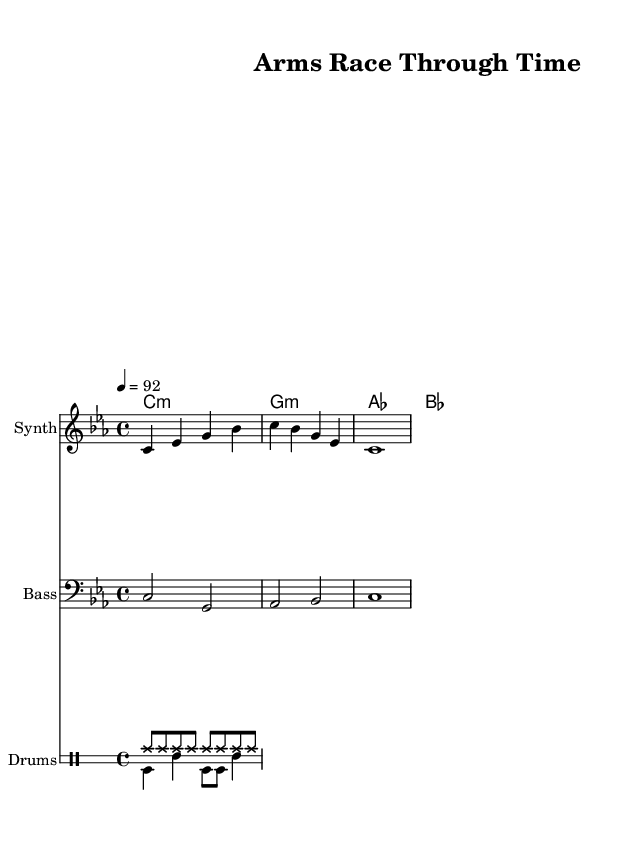What is the key signature of this music? The key signature for this piece is C minor, indicated by three flats in the signature at the beginning of the staff.
Answer: C minor What is the time signature of the music? The time signature is 4/4, found at the beginning of the score which indicates that there are four beats in each measure and a quarter note receives one beat.
Answer: 4/4 What is the tempo marking for this piece? The tempo marking is 92 beats per minute, represented in the tempo indication at the start of the score as "4 = 92".
Answer: 92 What instruments are featured in this score? The score features three instruments: Synth, Bass, and Drums. This is indicated by the instrument names at the beginning of each staff.
Answer: Synth, Bass, Drums In which measure does the melody start? The melody starts in measure 1, as that is the first measure of the staff where the melody notes are written.
Answer: 1 How many beats are in the longest note value in the melody? The longest note value in the melody is a whole note, which is equal to four beats, as seen in measure 3.
Answer: 4 How many chord changes are indicated throughout the piece? There are three chord changes shown in the chord names above the staffs, corresponding to the segments of the melody and bassline.
Answer: 3 